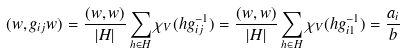<formula> <loc_0><loc_0><loc_500><loc_500>( w , g _ { i j } w ) = \frac { ( w , w ) } { | H | } \sum _ { h \in H } \chi _ { V } ( h g _ { i j } ^ { - 1 } ) = \frac { ( w , w ) } { | H | } \sum _ { h \in H } \chi _ { V } ( h g _ { i 1 } ^ { - 1 } ) = \frac { a _ { i } } { b }</formula> 